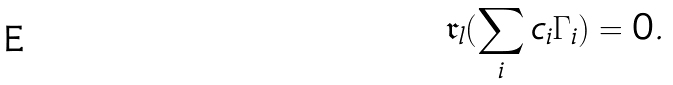Convert formula to latex. <formula><loc_0><loc_0><loc_500><loc_500>\mathfrak { r } _ { l } ( \sum _ { i } c _ { i } \Gamma _ { i } ) = 0 .</formula> 